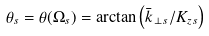<formula> <loc_0><loc_0><loc_500><loc_500>\theta _ { s } = \theta ( \Omega _ { s } ) = \arctan \left ( \bar { k } _ { \, \perp s } / K _ { z s } \right )</formula> 